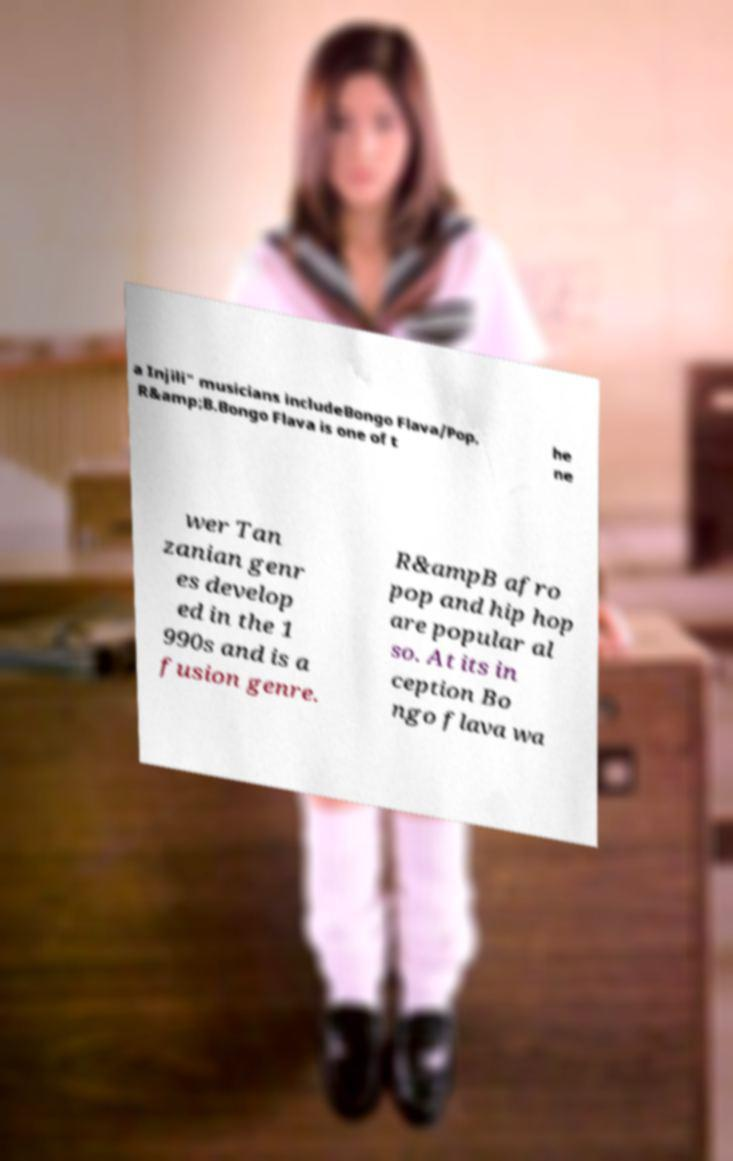Could you assist in decoding the text presented in this image and type it out clearly? a Injili" musicians includeBongo Flava/Pop, R&amp;B.Bongo Flava is one of t he ne wer Tan zanian genr es develop ed in the 1 990s and is a fusion genre. R&ampB afro pop and hip hop are popular al so. At its in ception Bo ngo flava wa 